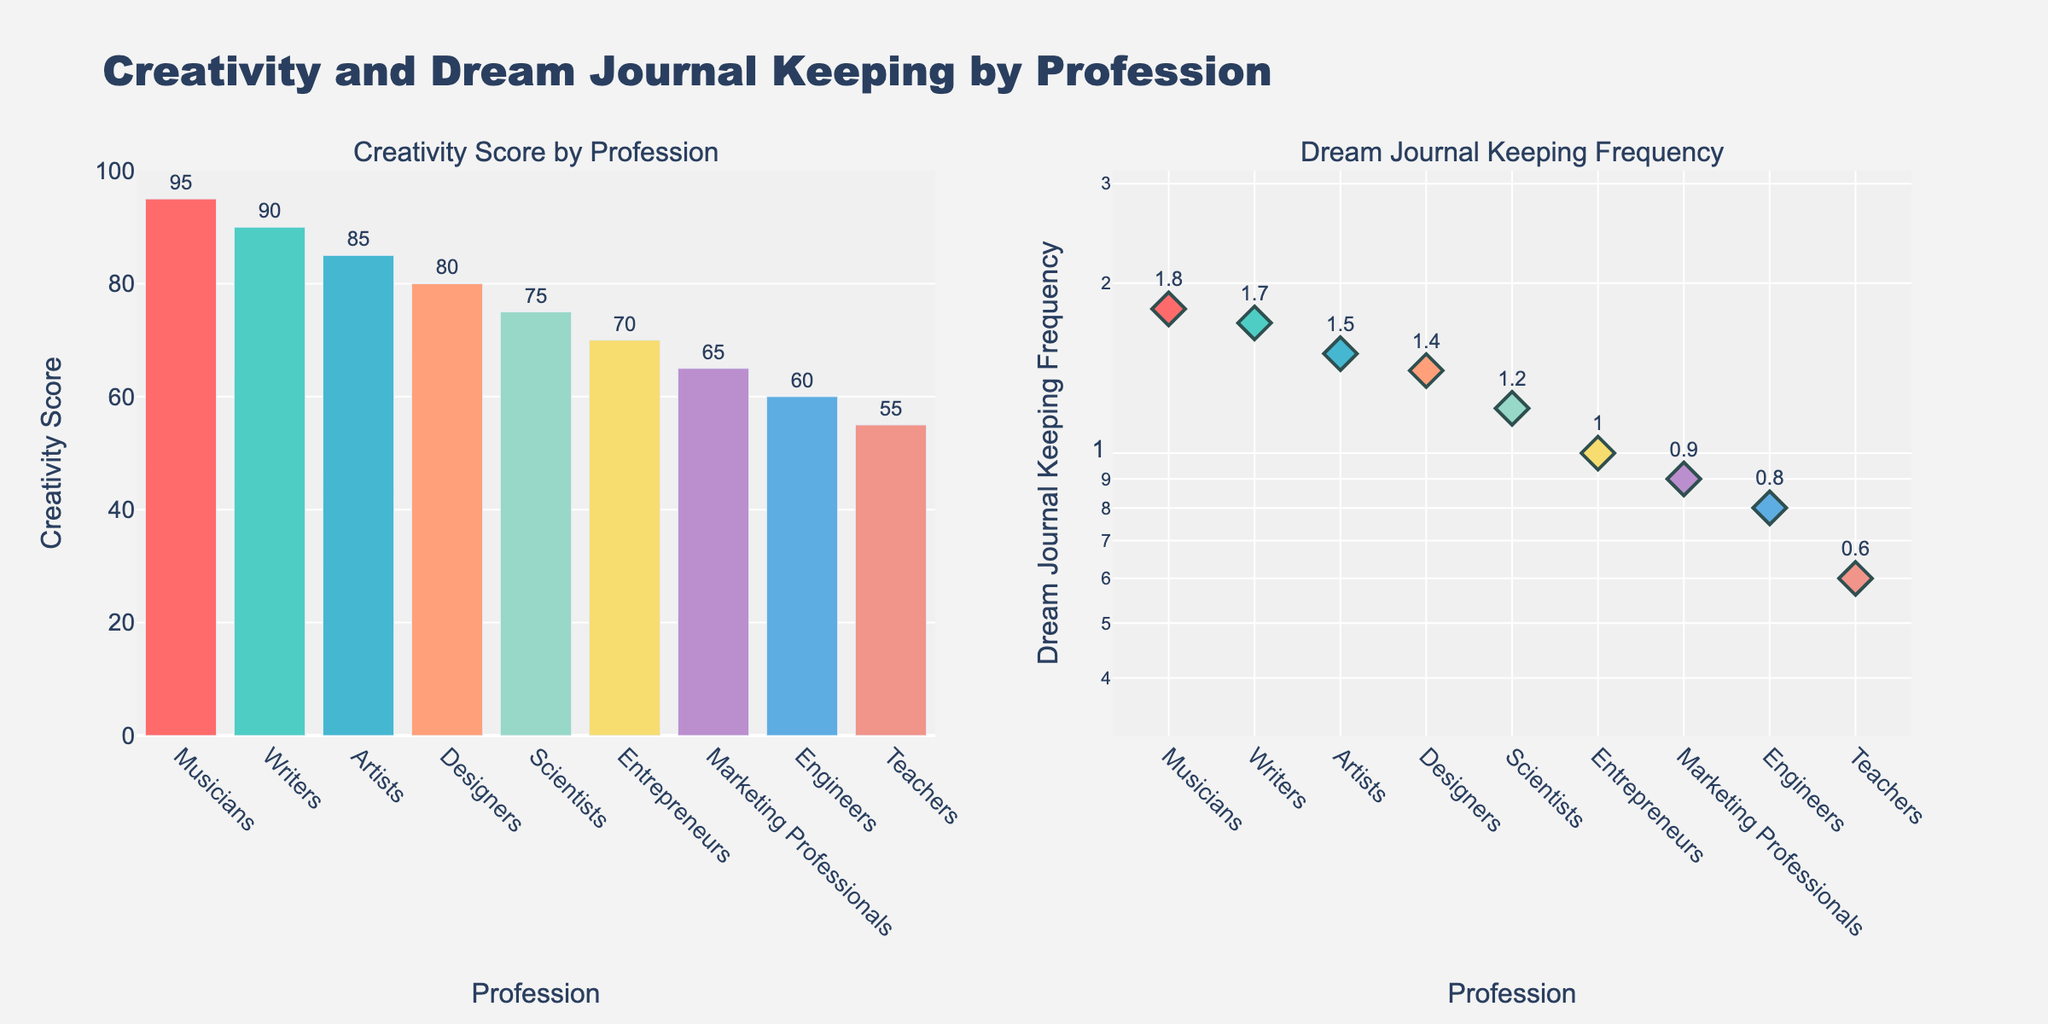What is the title of the figure? The title is located at the top of the figure and provides an overview of what the figure is about.
Answer: Creativity and Dream Journal Keeping by Profession Which profession has the highest creativity score? By looking at the heights of the bars in the "Creativity Score by Profession" subplot, the highest bar represents the profession with the highest score.
Answer: Musicians What is the dream journal keeping frequency for Engineers? The frequency for Engineers can be found in the "Dream Journal Keeping Frequency" subplot by identifying the corresponding marker for Engineers.
Answer: 0.8 How does the creativity score of Teachers compare to that of Writers? Compare the heights of the bars for Teachers and Writers in the "Creativity Score by Profession" subplot.
Answer: Teachers have a lower score than Writers What is the average creativity score across all professions? Sum all creativity scores provided and divide by the number of professions. (85 + 60 + 90 + 75 + 80 + 55 + 95 + 70 + 65) / 9 = 675 / 9 = 75
Answer: 75 Which profession has a dream journal keeping frequency closest to 1.5? Identify which marker in the "Dream Journal Keeping Frequency" subplot is closest to the y-axis value of 1.5.
Answer: Artists Is there a trend showing that higher dream journal keeping frequency corresponds to higher creativity scores? Look at the correlation in the figure between the professions with high keeping frequencies and high creativity scores.
Answer: Yes What's the difference in creativity scores between the lowest and the highest scoring professions? Subtract the creativity score of the lowest scoring profession (Teachers) from the highest scoring profession (Musicians). 95 - 55 = 40
Answer: 40 Which two professions have the most similar dream journal keeping frequencies? Look for the markers in the "Dream Journal Keeping Frequency" subplot that are closest together.
Answer: Entrepreneurs and Marketing Professionals 